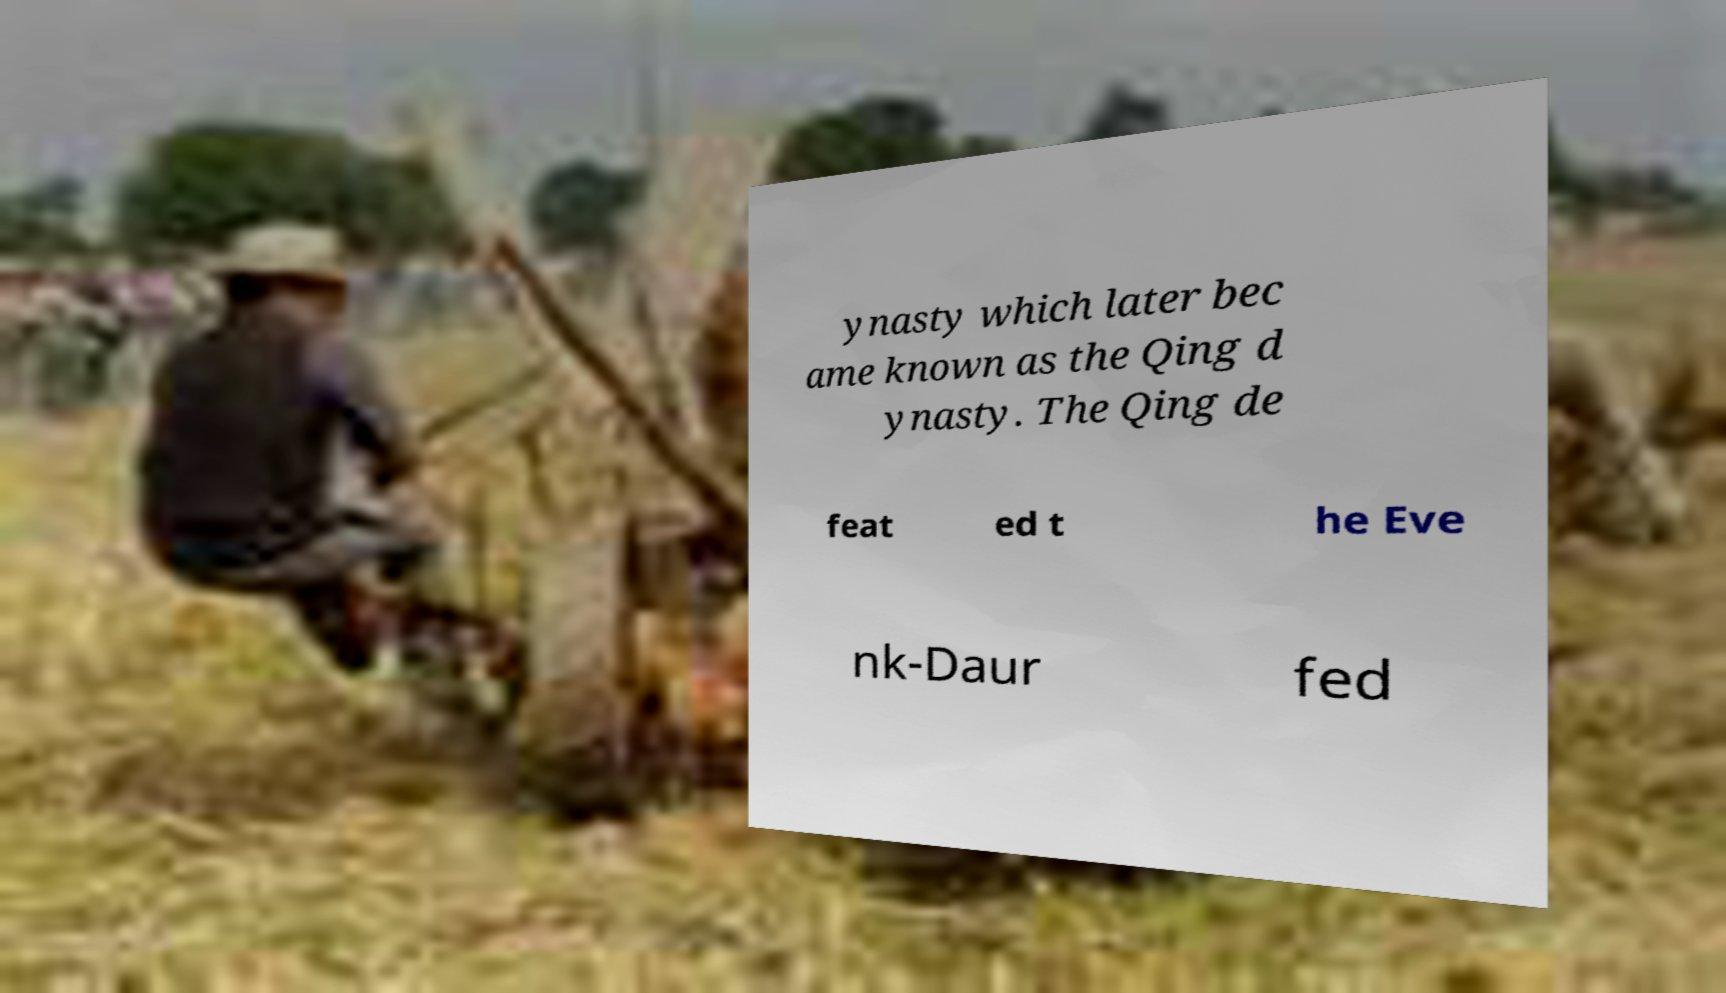I need the written content from this picture converted into text. Can you do that? ynasty which later bec ame known as the Qing d ynasty. The Qing de feat ed t he Eve nk-Daur fed 